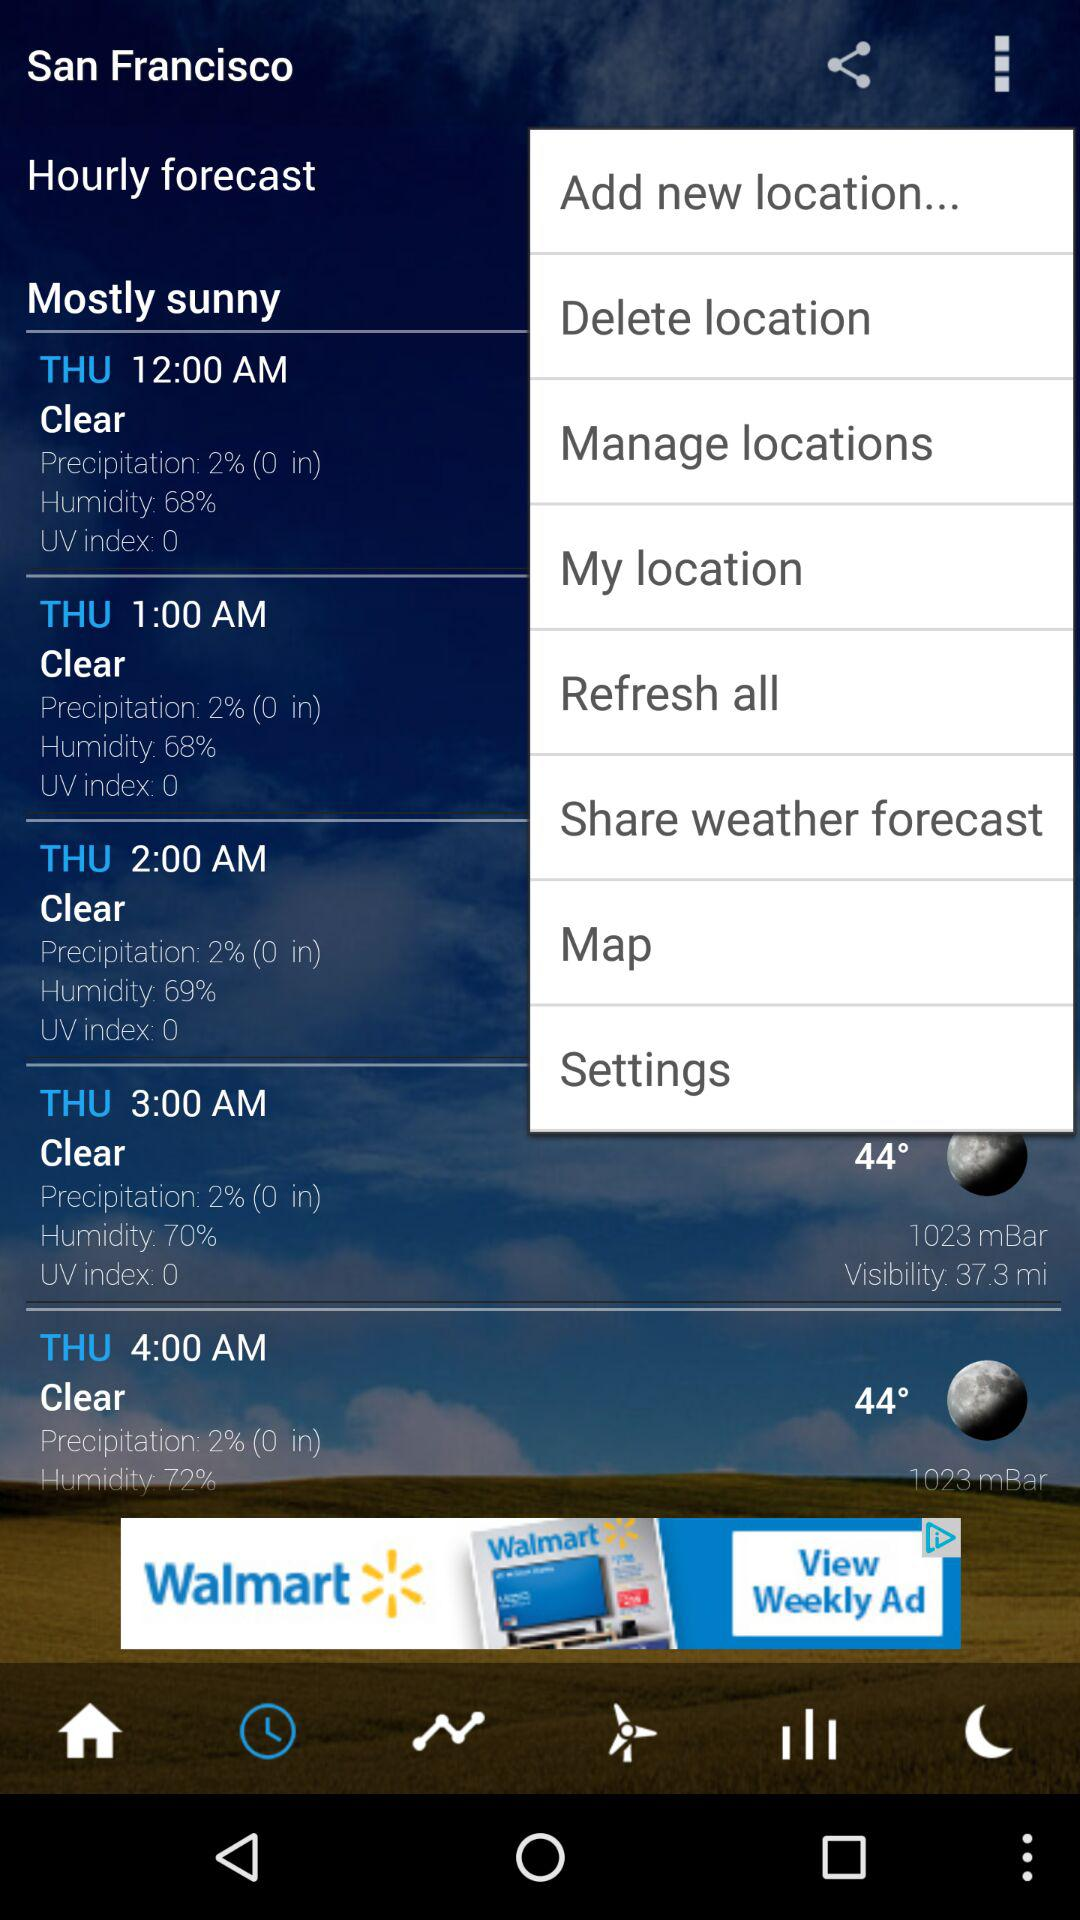What's the temperature at 4 a.m. Thursday? The temperature at 4 a.m. Thursday is 44 degrees. 